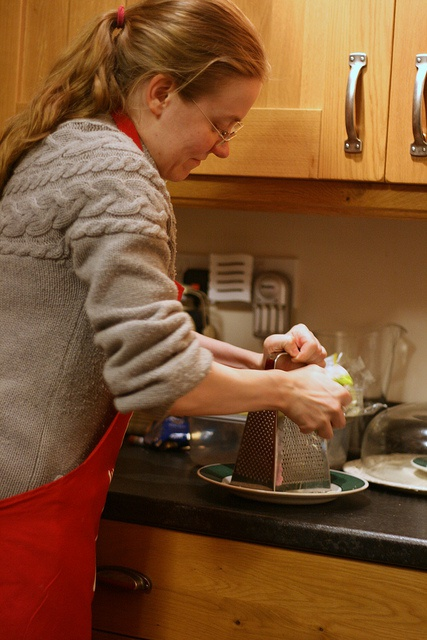Describe the objects in this image and their specific colors. I can see people in maroon, gray, and brown tones and cup in maroon, gray, olive, brown, and tan tones in this image. 